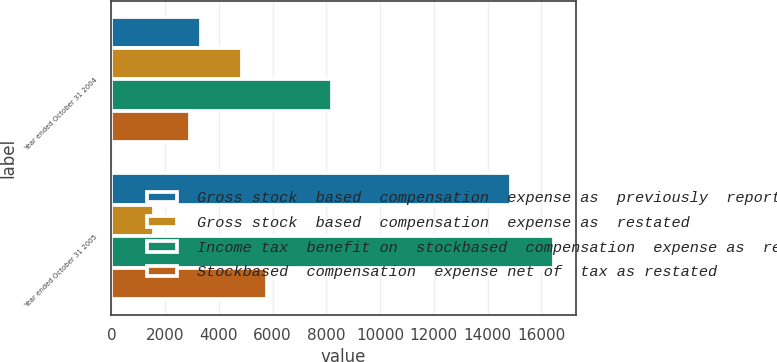Convert chart. <chart><loc_0><loc_0><loc_500><loc_500><stacked_bar_chart><ecel><fcel>Year ended October 31 2004<fcel>Year ended October 31 2005<nl><fcel>Gross stock  based  compensation  expense as  previously  reported<fcel>3331<fcel>14860<nl><fcel>Gross stock  based  compensation  expense as  restated<fcel>4866<fcel>1596<nl><fcel>Income tax  benefit on  stockbased  compensation  expense as  restated<fcel>8197<fcel>16456<nl><fcel>Stockbased  compensation  expense net of  tax as restated<fcel>2909<fcel>5806<nl></chart> 